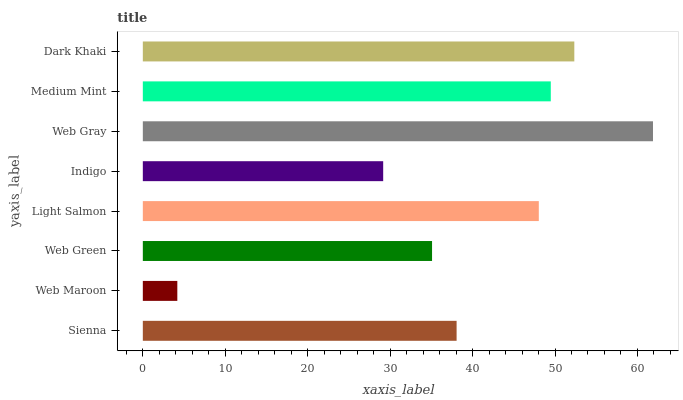Is Web Maroon the minimum?
Answer yes or no. Yes. Is Web Gray the maximum?
Answer yes or no. Yes. Is Web Green the minimum?
Answer yes or no. No. Is Web Green the maximum?
Answer yes or no. No. Is Web Green greater than Web Maroon?
Answer yes or no. Yes. Is Web Maroon less than Web Green?
Answer yes or no. Yes. Is Web Maroon greater than Web Green?
Answer yes or no. No. Is Web Green less than Web Maroon?
Answer yes or no. No. Is Light Salmon the high median?
Answer yes or no. Yes. Is Sienna the low median?
Answer yes or no. Yes. Is Web Maroon the high median?
Answer yes or no. No. Is Medium Mint the low median?
Answer yes or no. No. 